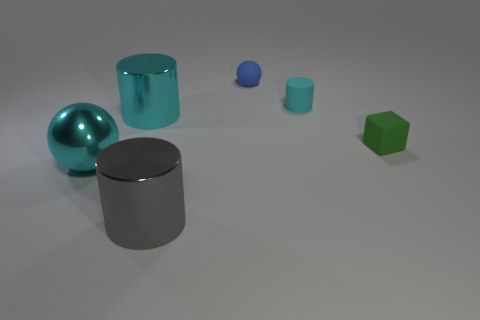Subtract all big cylinders. How many cylinders are left? 1 Subtract all brown cubes. How many cyan cylinders are left? 2 Subtract all cyan cylinders. How many cylinders are left? 1 Add 1 big purple rubber cylinders. How many objects exist? 7 Subtract 1 cylinders. How many cylinders are left? 2 Subtract all cubes. How many objects are left? 5 Subtract all green cylinders. Subtract all yellow blocks. How many cylinders are left? 3 Subtract all small gray balls. Subtract all green things. How many objects are left? 5 Add 3 green matte cubes. How many green matte cubes are left? 4 Add 1 cylinders. How many cylinders exist? 4 